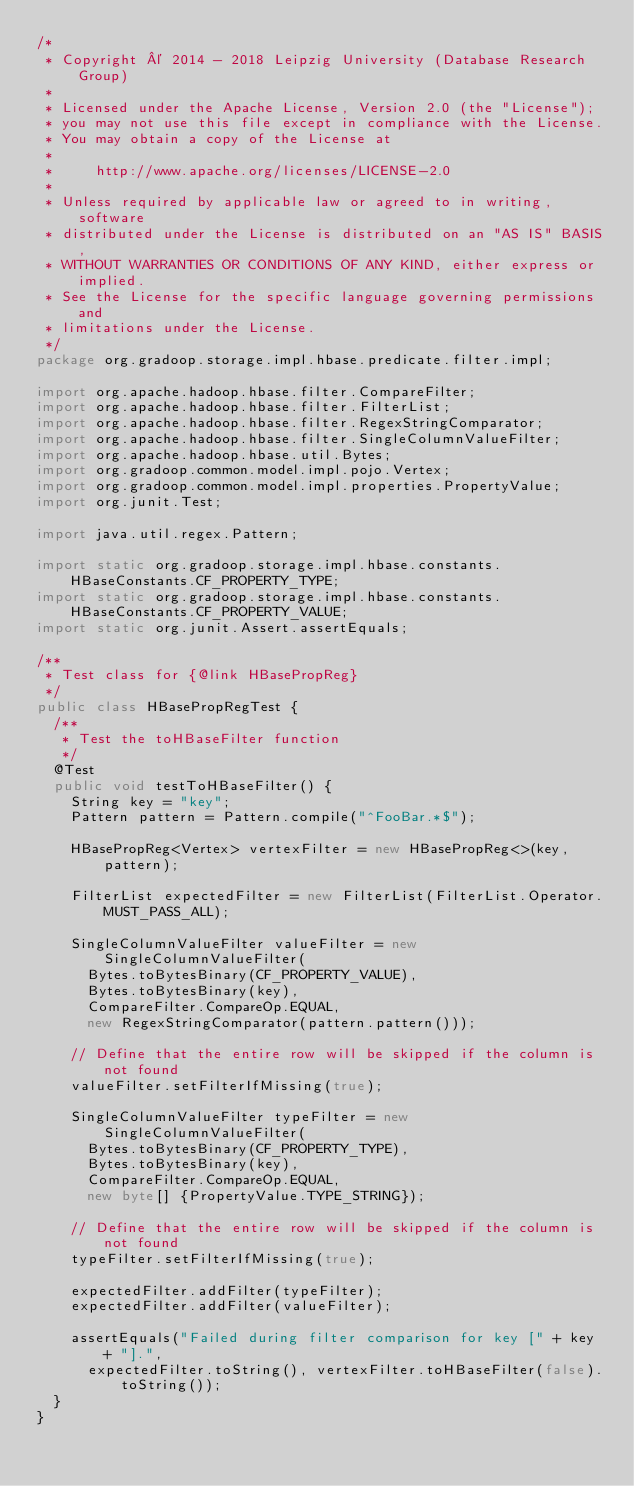<code> <loc_0><loc_0><loc_500><loc_500><_Java_>/*
 * Copyright © 2014 - 2018 Leipzig University (Database Research Group)
 *
 * Licensed under the Apache License, Version 2.0 (the "License");
 * you may not use this file except in compliance with the License.
 * You may obtain a copy of the License at
 *
 *     http://www.apache.org/licenses/LICENSE-2.0
 *
 * Unless required by applicable law or agreed to in writing, software
 * distributed under the License is distributed on an "AS IS" BASIS,
 * WITHOUT WARRANTIES OR CONDITIONS OF ANY KIND, either express or implied.
 * See the License for the specific language governing permissions and
 * limitations under the License.
 */
package org.gradoop.storage.impl.hbase.predicate.filter.impl;

import org.apache.hadoop.hbase.filter.CompareFilter;
import org.apache.hadoop.hbase.filter.FilterList;
import org.apache.hadoop.hbase.filter.RegexStringComparator;
import org.apache.hadoop.hbase.filter.SingleColumnValueFilter;
import org.apache.hadoop.hbase.util.Bytes;
import org.gradoop.common.model.impl.pojo.Vertex;
import org.gradoop.common.model.impl.properties.PropertyValue;
import org.junit.Test;

import java.util.regex.Pattern;

import static org.gradoop.storage.impl.hbase.constants.HBaseConstants.CF_PROPERTY_TYPE;
import static org.gradoop.storage.impl.hbase.constants.HBaseConstants.CF_PROPERTY_VALUE;
import static org.junit.Assert.assertEquals;

/**
 * Test class for {@link HBasePropReg}
 */
public class HBasePropRegTest {
  /**
   * Test the toHBaseFilter function
   */
  @Test
  public void testToHBaseFilter() {
    String key = "key";
    Pattern pattern = Pattern.compile("^FooBar.*$");

    HBasePropReg<Vertex> vertexFilter = new HBasePropReg<>(key, pattern);

    FilterList expectedFilter = new FilterList(FilterList.Operator.MUST_PASS_ALL);

    SingleColumnValueFilter valueFilter = new SingleColumnValueFilter(
      Bytes.toBytesBinary(CF_PROPERTY_VALUE),
      Bytes.toBytesBinary(key),
      CompareFilter.CompareOp.EQUAL,
      new RegexStringComparator(pattern.pattern()));

    // Define that the entire row will be skipped if the column is not found
    valueFilter.setFilterIfMissing(true);

    SingleColumnValueFilter typeFilter = new SingleColumnValueFilter(
      Bytes.toBytesBinary(CF_PROPERTY_TYPE),
      Bytes.toBytesBinary(key),
      CompareFilter.CompareOp.EQUAL,
      new byte[] {PropertyValue.TYPE_STRING});

    // Define that the entire row will be skipped if the column is not found
    typeFilter.setFilterIfMissing(true);

    expectedFilter.addFilter(typeFilter);
    expectedFilter.addFilter(valueFilter);

    assertEquals("Failed during filter comparison for key [" + key + "].",
      expectedFilter.toString(), vertexFilter.toHBaseFilter(false).toString());
  }
}
</code> 